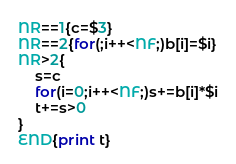Convert code to text. <code><loc_0><loc_0><loc_500><loc_500><_Awk_>NR==1{c=$3}
NR==2{for(;i++<NF;)b[i]=$i}
NR>2{
	s=c
	for(i=0;i++<NF;)s+=b[i]*$i
	t+=s>0
}
END{print t}</code> 